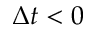Convert formula to latex. <formula><loc_0><loc_0><loc_500><loc_500>\Delta t < 0</formula> 